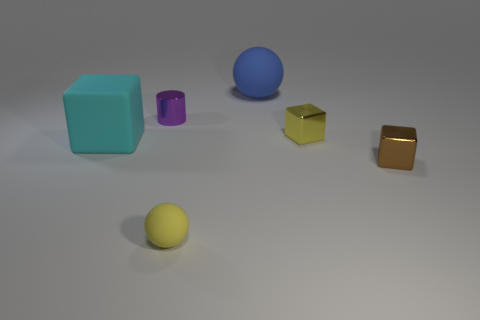There is another object that is the same color as the tiny rubber thing; what shape is it?
Your answer should be very brief. Cube. There is a metal thing on the left side of the metallic block behind the block on the left side of the big blue object; what is its shape?
Provide a short and direct response. Cylinder. How many things are either shiny things that are behind the cyan rubber block or cubes left of the yellow matte ball?
Your answer should be compact. 3. There is a yellow thing to the left of the sphere right of the small yellow ball; how big is it?
Give a very brief answer. Small. Do the tiny metallic block that is on the right side of the tiny yellow metallic cube and the big ball have the same color?
Offer a terse response. No. Is there a purple metallic object of the same shape as the big cyan object?
Keep it short and to the point. No. What is the color of the rubber ball that is the same size as the cyan object?
Provide a succinct answer. Blue. There is a yellow object in front of the big cube; what is its size?
Make the answer very short. Small. There is a metal cylinder right of the big cyan matte block; are there any cylinders that are to the left of it?
Provide a short and direct response. No. Is the cube that is left of the tiny purple object made of the same material as the yellow cube?
Give a very brief answer. No. 